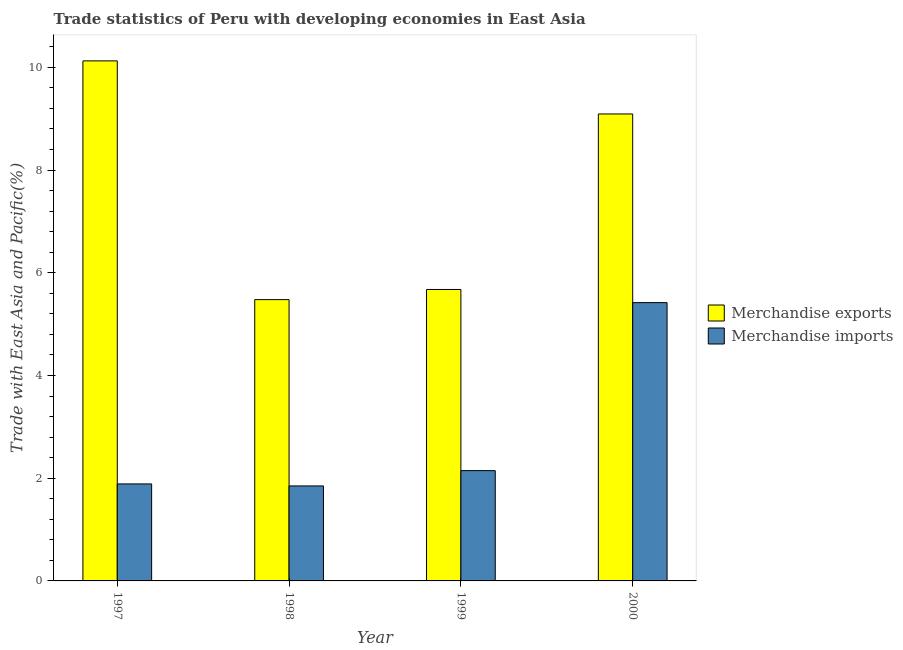How many groups of bars are there?
Make the answer very short. 4. Are the number of bars per tick equal to the number of legend labels?
Your response must be concise. Yes. How many bars are there on the 2nd tick from the right?
Offer a very short reply. 2. In how many cases, is the number of bars for a given year not equal to the number of legend labels?
Your answer should be compact. 0. What is the merchandise imports in 1998?
Your response must be concise. 1.85. Across all years, what is the maximum merchandise imports?
Your response must be concise. 5.42. Across all years, what is the minimum merchandise exports?
Keep it short and to the point. 5.48. In which year was the merchandise exports maximum?
Your response must be concise. 1997. In which year was the merchandise exports minimum?
Your answer should be compact. 1998. What is the total merchandise imports in the graph?
Provide a short and direct response. 11.31. What is the difference between the merchandise exports in 1999 and that in 2000?
Keep it short and to the point. -3.42. What is the difference between the merchandise exports in 2000 and the merchandise imports in 1997?
Offer a terse response. -1.03. What is the average merchandise exports per year?
Give a very brief answer. 7.59. In how many years, is the merchandise imports greater than 4.8 %?
Ensure brevity in your answer.  1. What is the ratio of the merchandise imports in 1997 to that in 1998?
Give a very brief answer. 1.02. Is the merchandise imports in 1998 less than that in 2000?
Provide a succinct answer. Yes. Is the difference between the merchandise exports in 1997 and 2000 greater than the difference between the merchandise imports in 1997 and 2000?
Keep it short and to the point. No. What is the difference between the highest and the second highest merchandise exports?
Give a very brief answer. 1.03. What is the difference between the highest and the lowest merchandise exports?
Offer a terse response. 4.65. Is the sum of the merchandise imports in 1998 and 2000 greater than the maximum merchandise exports across all years?
Your answer should be compact. Yes. Are all the bars in the graph horizontal?
Offer a terse response. No. Are the values on the major ticks of Y-axis written in scientific E-notation?
Your answer should be compact. No. Where does the legend appear in the graph?
Ensure brevity in your answer.  Center right. What is the title of the graph?
Give a very brief answer. Trade statistics of Peru with developing economies in East Asia. Does "National Tourists" appear as one of the legend labels in the graph?
Provide a succinct answer. No. What is the label or title of the Y-axis?
Your response must be concise. Trade with East Asia and Pacific(%). What is the Trade with East Asia and Pacific(%) in Merchandise exports in 1997?
Ensure brevity in your answer.  10.13. What is the Trade with East Asia and Pacific(%) of Merchandise imports in 1997?
Provide a succinct answer. 1.89. What is the Trade with East Asia and Pacific(%) in Merchandise exports in 1998?
Give a very brief answer. 5.48. What is the Trade with East Asia and Pacific(%) of Merchandise imports in 1998?
Offer a terse response. 1.85. What is the Trade with East Asia and Pacific(%) of Merchandise exports in 1999?
Your answer should be very brief. 5.68. What is the Trade with East Asia and Pacific(%) of Merchandise imports in 1999?
Offer a terse response. 2.15. What is the Trade with East Asia and Pacific(%) in Merchandise exports in 2000?
Ensure brevity in your answer.  9.09. What is the Trade with East Asia and Pacific(%) of Merchandise imports in 2000?
Offer a very short reply. 5.42. Across all years, what is the maximum Trade with East Asia and Pacific(%) in Merchandise exports?
Your response must be concise. 10.13. Across all years, what is the maximum Trade with East Asia and Pacific(%) in Merchandise imports?
Your answer should be very brief. 5.42. Across all years, what is the minimum Trade with East Asia and Pacific(%) in Merchandise exports?
Ensure brevity in your answer.  5.48. Across all years, what is the minimum Trade with East Asia and Pacific(%) of Merchandise imports?
Your response must be concise. 1.85. What is the total Trade with East Asia and Pacific(%) in Merchandise exports in the graph?
Ensure brevity in your answer.  30.37. What is the total Trade with East Asia and Pacific(%) in Merchandise imports in the graph?
Offer a very short reply. 11.31. What is the difference between the Trade with East Asia and Pacific(%) in Merchandise exports in 1997 and that in 1998?
Your answer should be compact. 4.65. What is the difference between the Trade with East Asia and Pacific(%) in Merchandise imports in 1997 and that in 1998?
Your answer should be very brief. 0.04. What is the difference between the Trade with East Asia and Pacific(%) of Merchandise exports in 1997 and that in 1999?
Keep it short and to the point. 4.45. What is the difference between the Trade with East Asia and Pacific(%) in Merchandise imports in 1997 and that in 1999?
Provide a succinct answer. -0.26. What is the difference between the Trade with East Asia and Pacific(%) of Merchandise exports in 1997 and that in 2000?
Make the answer very short. 1.03. What is the difference between the Trade with East Asia and Pacific(%) in Merchandise imports in 1997 and that in 2000?
Make the answer very short. -3.53. What is the difference between the Trade with East Asia and Pacific(%) in Merchandise exports in 1998 and that in 1999?
Offer a terse response. -0.2. What is the difference between the Trade with East Asia and Pacific(%) of Merchandise imports in 1998 and that in 1999?
Make the answer very short. -0.3. What is the difference between the Trade with East Asia and Pacific(%) of Merchandise exports in 1998 and that in 2000?
Provide a short and direct response. -3.62. What is the difference between the Trade with East Asia and Pacific(%) in Merchandise imports in 1998 and that in 2000?
Keep it short and to the point. -3.57. What is the difference between the Trade with East Asia and Pacific(%) of Merchandise exports in 1999 and that in 2000?
Provide a short and direct response. -3.42. What is the difference between the Trade with East Asia and Pacific(%) of Merchandise imports in 1999 and that in 2000?
Give a very brief answer. -3.27. What is the difference between the Trade with East Asia and Pacific(%) in Merchandise exports in 1997 and the Trade with East Asia and Pacific(%) in Merchandise imports in 1998?
Give a very brief answer. 8.28. What is the difference between the Trade with East Asia and Pacific(%) of Merchandise exports in 1997 and the Trade with East Asia and Pacific(%) of Merchandise imports in 1999?
Provide a succinct answer. 7.98. What is the difference between the Trade with East Asia and Pacific(%) in Merchandise exports in 1997 and the Trade with East Asia and Pacific(%) in Merchandise imports in 2000?
Provide a succinct answer. 4.71. What is the difference between the Trade with East Asia and Pacific(%) in Merchandise exports in 1998 and the Trade with East Asia and Pacific(%) in Merchandise imports in 1999?
Provide a short and direct response. 3.33. What is the difference between the Trade with East Asia and Pacific(%) in Merchandise exports in 1998 and the Trade with East Asia and Pacific(%) in Merchandise imports in 2000?
Give a very brief answer. 0.06. What is the difference between the Trade with East Asia and Pacific(%) in Merchandise exports in 1999 and the Trade with East Asia and Pacific(%) in Merchandise imports in 2000?
Keep it short and to the point. 0.26. What is the average Trade with East Asia and Pacific(%) in Merchandise exports per year?
Provide a short and direct response. 7.59. What is the average Trade with East Asia and Pacific(%) in Merchandise imports per year?
Ensure brevity in your answer.  2.83. In the year 1997, what is the difference between the Trade with East Asia and Pacific(%) of Merchandise exports and Trade with East Asia and Pacific(%) of Merchandise imports?
Offer a very short reply. 8.24. In the year 1998, what is the difference between the Trade with East Asia and Pacific(%) in Merchandise exports and Trade with East Asia and Pacific(%) in Merchandise imports?
Your answer should be very brief. 3.63. In the year 1999, what is the difference between the Trade with East Asia and Pacific(%) of Merchandise exports and Trade with East Asia and Pacific(%) of Merchandise imports?
Your answer should be compact. 3.53. In the year 2000, what is the difference between the Trade with East Asia and Pacific(%) in Merchandise exports and Trade with East Asia and Pacific(%) in Merchandise imports?
Your response must be concise. 3.67. What is the ratio of the Trade with East Asia and Pacific(%) in Merchandise exports in 1997 to that in 1998?
Ensure brevity in your answer.  1.85. What is the ratio of the Trade with East Asia and Pacific(%) in Merchandise imports in 1997 to that in 1998?
Keep it short and to the point. 1.02. What is the ratio of the Trade with East Asia and Pacific(%) of Merchandise exports in 1997 to that in 1999?
Make the answer very short. 1.78. What is the ratio of the Trade with East Asia and Pacific(%) of Merchandise imports in 1997 to that in 1999?
Your answer should be compact. 0.88. What is the ratio of the Trade with East Asia and Pacific(%) in Merchandise exports in 1997 to that in 2000?
Offer a very short reply. 1.11. What is the ratio of the Trade with East Asia and Pacific(%) in Merchandise imports in 1997 to that in 2000?
Offer a very short reply. 0.35. What is the ratio of the Trade with East Asia and Pacific(%) in Merchandise exports in 1998 to that in 1999?
Provide a succinct answer. 0.97. What is the ratio of the Trade with East Asia and Pacific(%) of Merchandise imports in 1998 to that in 1999?
Offer a very short reply. 0.86. What is the ratio of the Trade with East Asia and Pacific(%) in Merchandise exports in 1998 to that in 2000?
Your answer should be very brief. 0.6. What is the ratio of the Trade with East Asia and Pacific(%) in Merchandise imports in 1998 to that in 2000?
Your answer should be compact. 0.34. What is the ratio of the Trade with East Asia and Pacific(%) in Merchandise exports in 1999 to that in 2000?
Your response must be concise. 0.62. What is the ratio of the Trade with East Asia and Pacific(%) in Merchandise imports in 1999 to that in 2000?
Your answer should be compact. 0.4. What is the difference between the highest and the second highest Trade with East Asia and Pacific(%) of Merchandise exports?
Ensure brevity in your answer.  1.03. What is the difference between the highest and the second highest Trade with East Asia and Pacific(%) of Merchandise imports?
Ensure brevity in your answer.  3.27. What is the difference between the highest and the lowest Trade with East Asia and Pacific(%) in Merchandise exports?
Your answer should be very brief. 4.65. What is the difference between the highest and the lowest Trade with East Asia and Pacific(%) of Merchandise imports?
Your answer should be very brief. 3.57. 